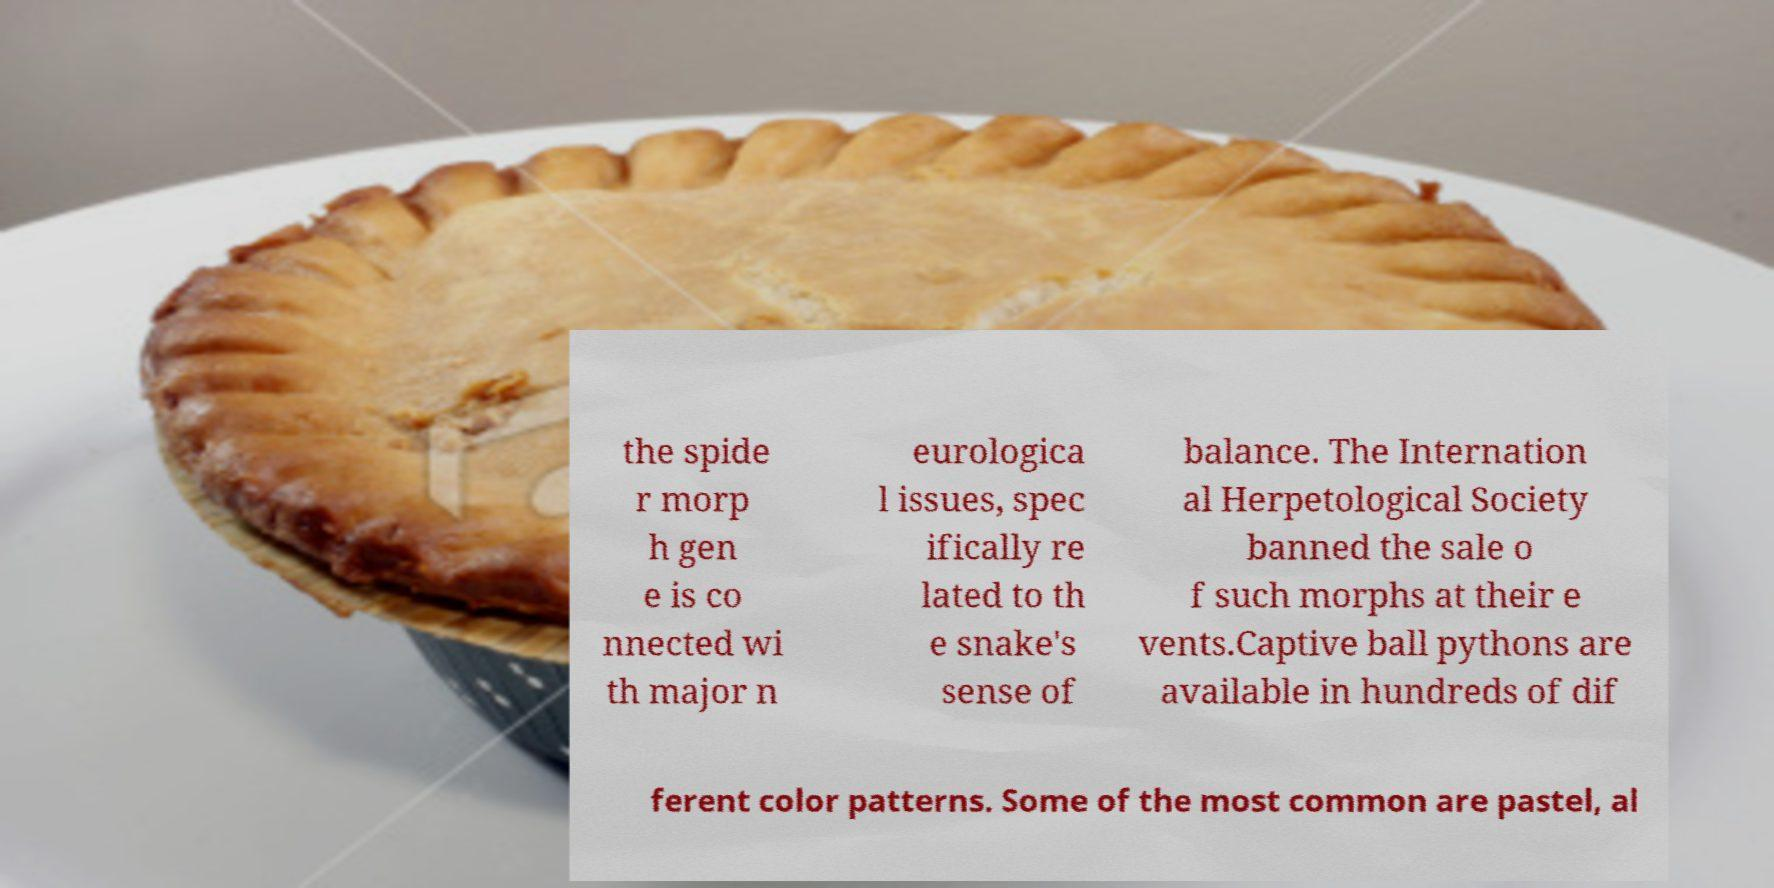What messages or text are displayed in this image? I need them in a readable, typed format. the spide r morp h gen e is co nnected wi th major n eurologica l issues, spec ifically re lated to th e snake's sense of balance. The Internation al Herpetological Society banned the sale o f such morphs at their e vents.Captive ball pythons are available in hundreds of dif ferent color patterns. Some of the most common are pastel, al 